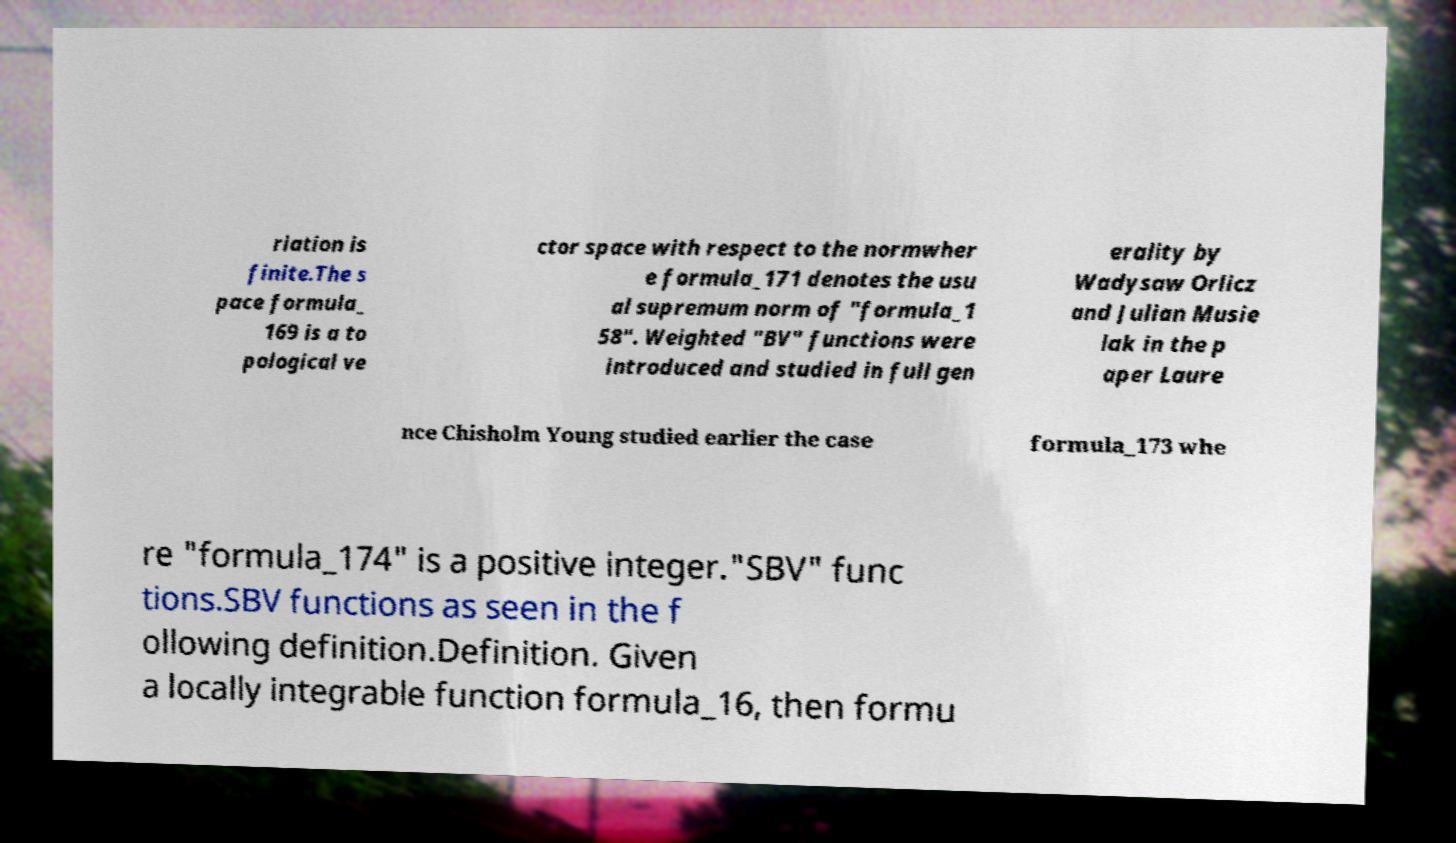Could you extract and type out the text from this image? riation is finite.The s pace formula_ 169 is a to pological ve ctor space with respect to the normwher e formula_171 denotes the usu al supremum norm of "formula_1 58". Weighted "BV" functions were introduced and studied in full gen erality by Wadysaw Orlicz and Julian Musie lak in the p aper Laure nce Chisholm Young studied earlier the case formula_173 whe re "formula_174" is a positive integer."SBV" func tions.SBV functions as seen in the f ollowing definition.Definition. Given a locally integrable function formula_16, then formu 